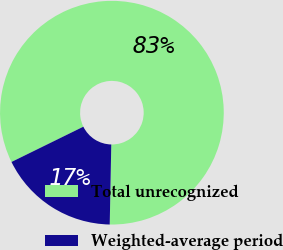Convert chart to OTSL. <chart><loc_0><loc_0><loc_500><loc_500><pie_chart><fcel>Total unrecognized<fcel>Weighted-average period<nl><fcel>82.57%<fcel>17.43%<nl></chart> 